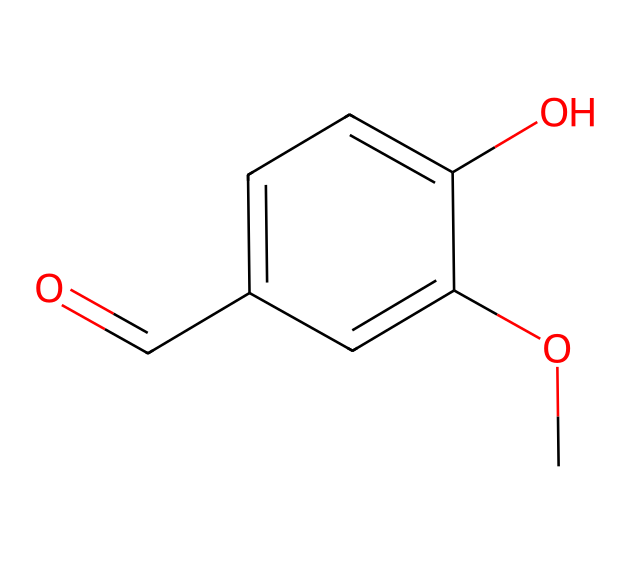What is the molecular formula of this compound? The SMILES representation can be parsed to determine the number of each type of atom present. In this case, the structure has 8 carbon atoms, 8 hydrogen atoms, and 3 oxygen atoms, leading to the molecular formula C8H8O3.
Answer: C8H8O3 How many hydroxyl groups are present in this molecule? A hydroxyl group is characterized by the presence of an -OH functional group. In the given structure, one of the oxygen atoms is attached to a hydrogen atom, indicating the presence of one hydroxyl group.
Answer: one What type of compound is this? This compound contains a benzene ring and functional groups typical of flavors and fragrances, specifically one hydroxyl and one methoxy group, making it categorized as a phenolic compound.
Answer: phenolic Which functional groups are present in this compound? To identify functional groups, look for specific arrangements of atoms. The presence of -OH indicates a hydroxyl group, while -O-CH3 indicates a methoxy group. There are thus a hydroxyl group and a methoxy group in this molecule.
Answer: hydroxyl and methoxy How does the presence of the methoxy group affect the aroma of this compound? The methoxy group specifically contributes to the structural characteristics that enhance this compound's sweet and creamy flavor, which is associated with the aroma of vanilla. Methoxy groups generally enhance flavor profiles in flavor-bearing compounds.
Answer: enhances sweetness What type of bonding primarily characterizes the connectivity in this molecule? The connectivity of the atoms can be analyzed by observing the structure: there are single bonds connecting most carbons surrounded by possible resonance stabilization due to the aromatic nature of the benzene ring. This implies a combination of covalent bonds and resonance in its connectivity.
Answer: covalent bonds How many rings are present in this molecule? In the chemical structure derived from the SMILES notation, observing the cyclic structure reveals that there is one ring present, which is the benzene ring.
Answer: one 